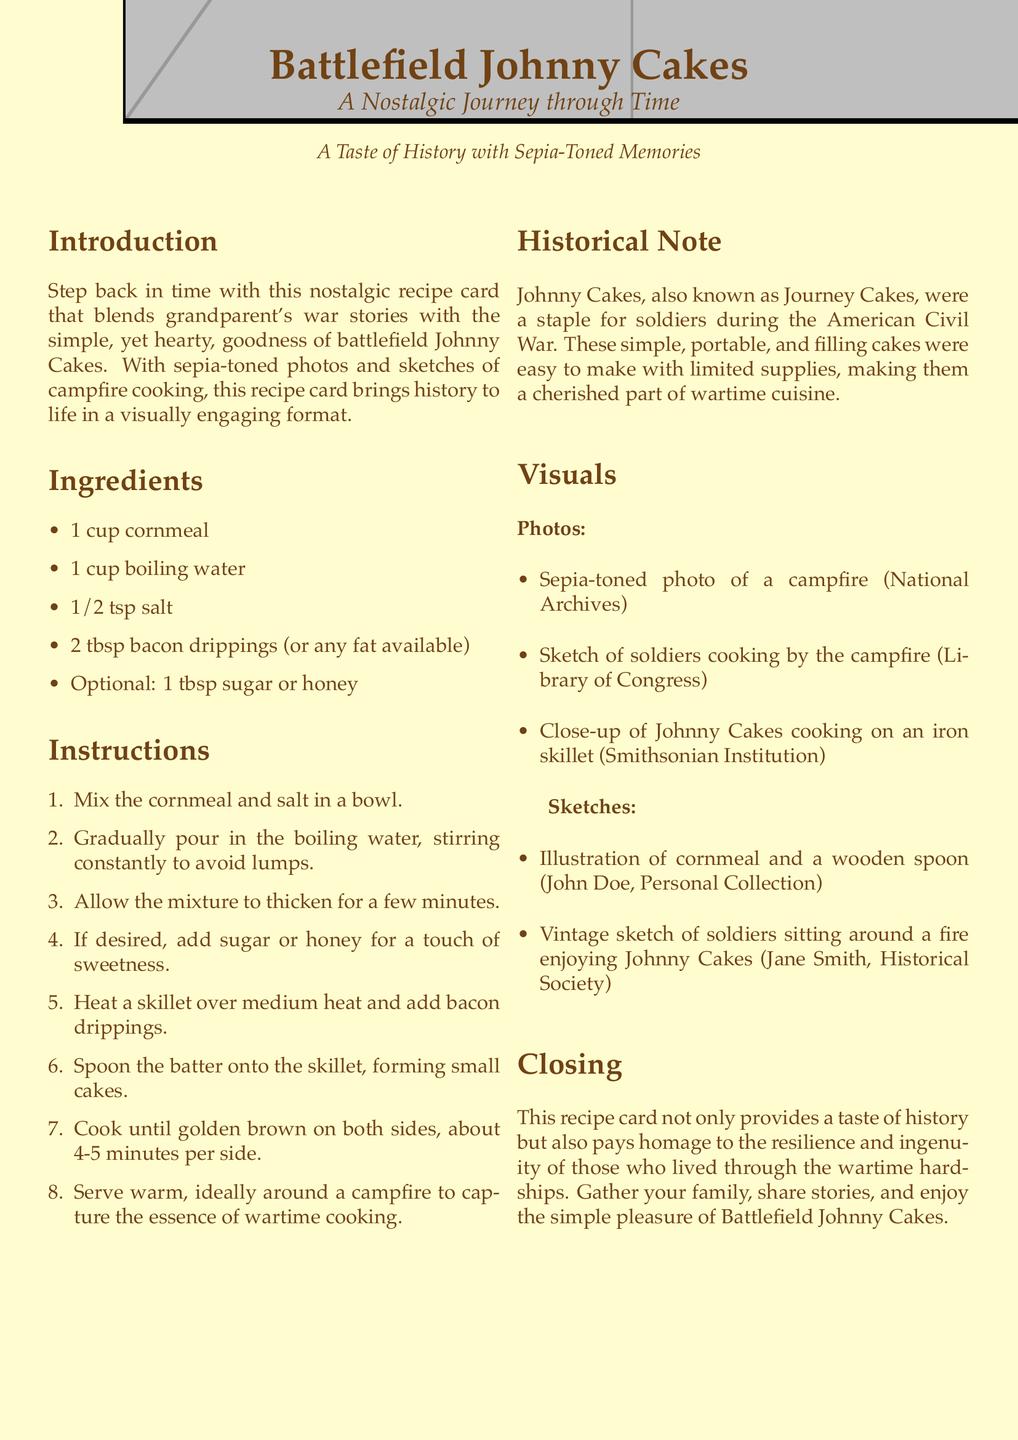What is the title of the recipe? The title of the recipe is prominently displayed at the beginning of the document, which is "Battlefield Johnny Cakes."
Answer: Battlefield Johnny Cakes What type of photo is used in the document? The document describes the use of sepia-toned photos to evoke nostalgia.
Answer: Sepia-toned How many cups of cornmeal are needed? The ingredients list specifically states the amount of cornmeal required for the recipe.
Answer: 1 cup What optional ingredient can be added for sweetness? The recipe mentions sugar or honey as an optional ingredient.
Answer: Sugar or honey What was the historical significance of Johnny Cakes? The historical note explains that Johnny Cakes were a staple for soldiers during the American Civil War.
Answer: Civil War How long should the cakes be cooked on each side? The instructions detail the cooking time for the cakes, which is stated clearly.
Answer: 4-5 minutes Who contributed the sketches of soldiers cooking by the campfire? The visuals section attributes a sketch of soldiers to a specific archive.
Answer: Library of Congress What is the primary cooking method described? The instructions guide the preparation of the recipe, highlighting the preferred technique.
Answer: Skillet cooking What is the main color theme of the document? The document indicates the use of cream and sepia colors throughout.
Answer: Cream and sepia 